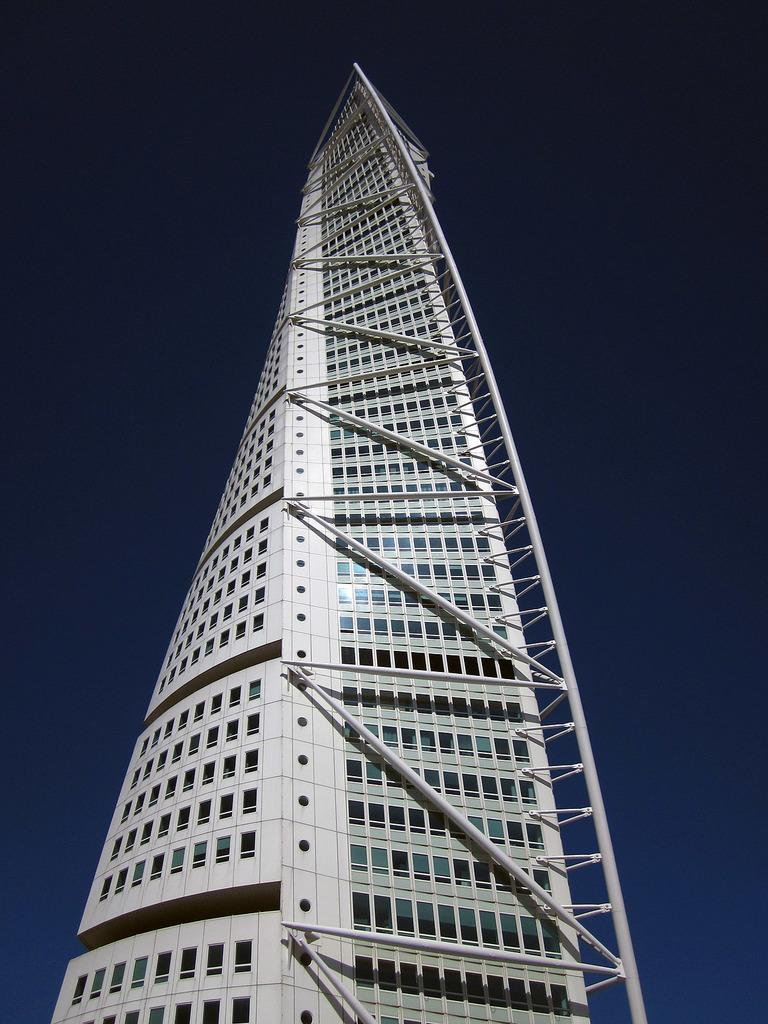What is the main subject in the center of the image? There is a skyscraper in the center of the image. What can be seen in the background of the image? The sky is visible in the background of the image. What type of basin is visible in the image? There is no basin present in the image. What shocking event is taking place in the image? There is no shocking event depicted in the image; it simply features a skyscraper and the sky. 